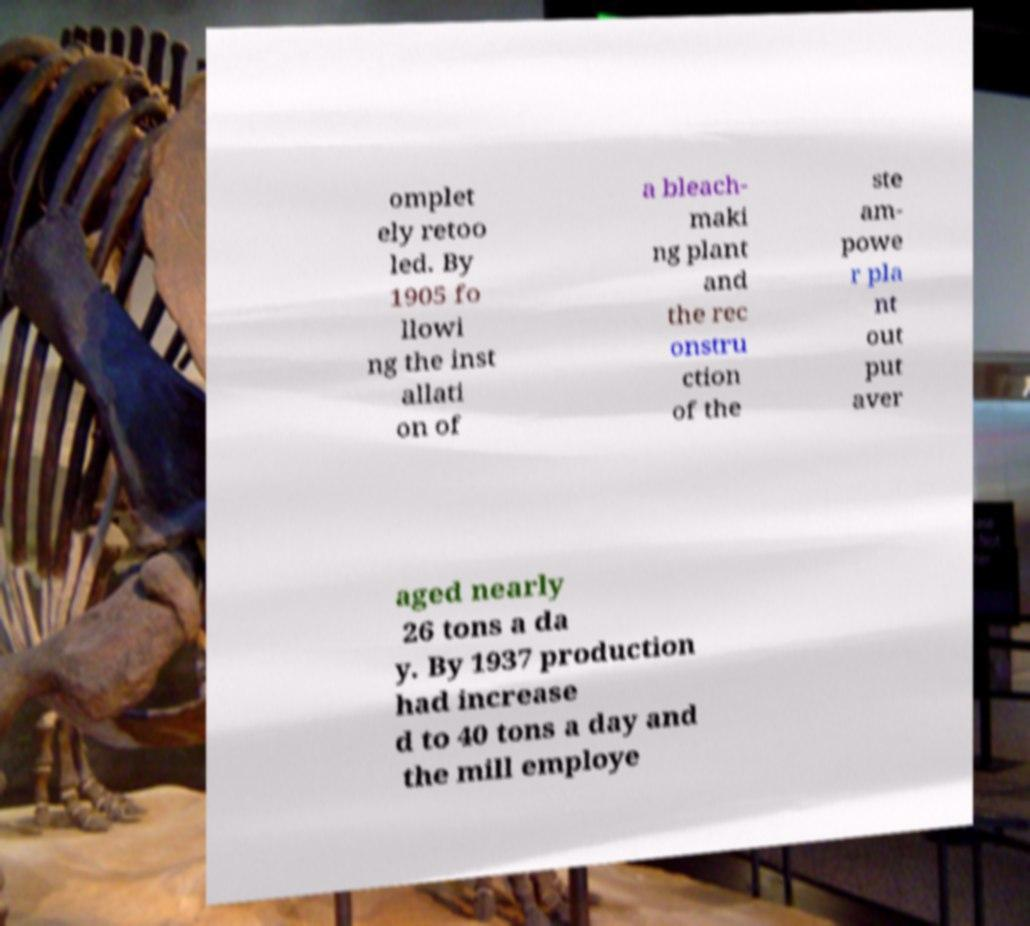There's text embedded in this image that I need extracted. Can you transcribe it verbatim? omplet ely retoo led. By 1905 fo llowi ng the inst allati on of a bleach- maki ng plant and the rec onstru ction of the ste am- powe r pla nt out put aver aged nearly 26 tons a da y. By 1937 production had increase d to 40 tons a day and the mill employe 